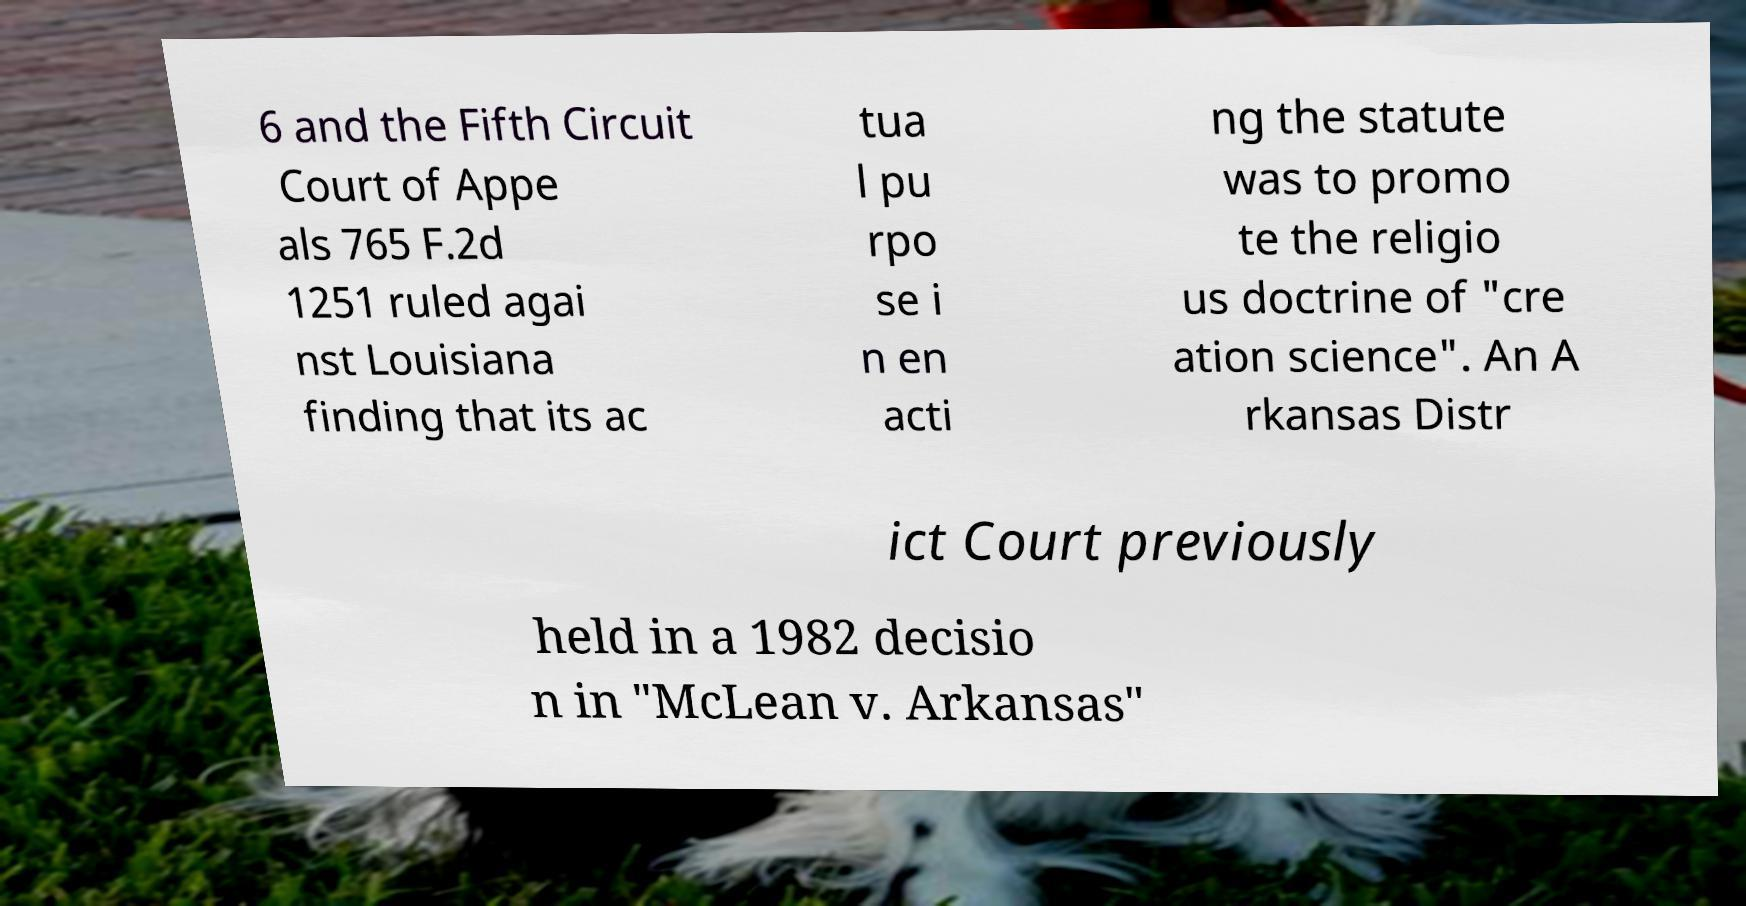Can you accurately transcribe the text from the provided image for me? 6 and the Fifth Circuit Court of Appe als 765 F.2d 1251 ruled agai nst Louisiana finding that its ac tua l pu rpo se i n en acti ng the statute was to promo te the religio us doctrine of "cre ation science". An A rkansas Distr ict Court previously held in a 1982 decisio n in "McLean v. Arkansas" 